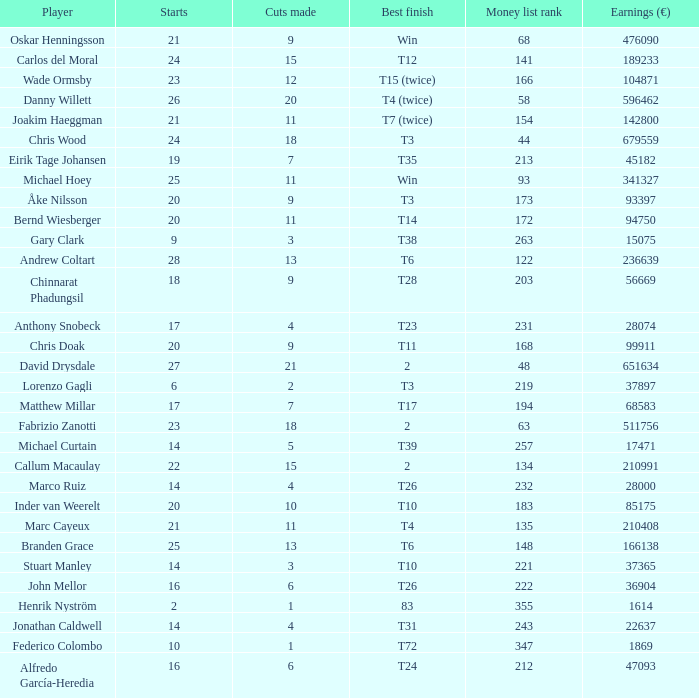What is the number of cuts made by bernd wiesberger? 11.0. 